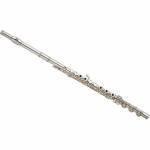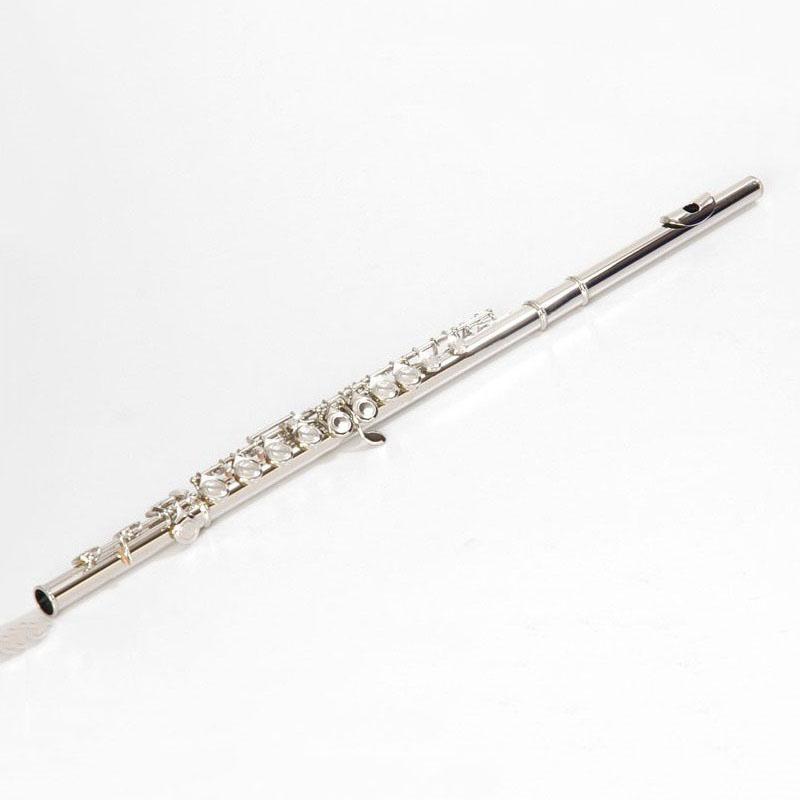The first image is the image on the left, the second image is the image on the right. Given the left and right images, does the statement "The flute-like instruments on the left and right are silver colored and displayed at opposite angles so they form a V shape." hold true? Answer yes or no. Yes. The first image is the image on the left, the second image is the image on the right. Assess this claim about the two images: "The left and right image contains the same number of silver flutes the are opposite facing.". Correct or not? Answer yes or no. Yes. 